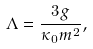Convert formula to latex. <formula><loc_0><loc_0><loc_500><loc_500>\Lambda = \frac { 3 g } { \kappa _ { 0 } m ^ { 2 } } ,</formula> 